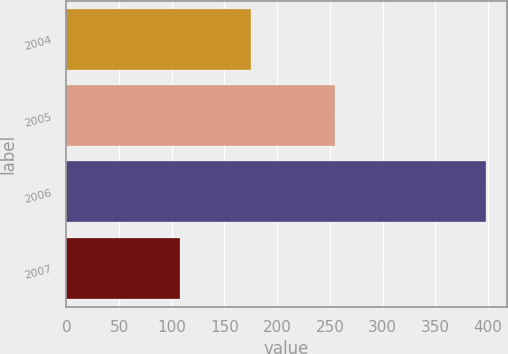<chart> <loc_0><loc_0><loc_500><loc_500><bar_chart><fcel>2004<fcel>2005<fcel>2006<fcel>2007<nl><fcel>175<fcel>255<fcel>398<fcel>108<nl></chart> 